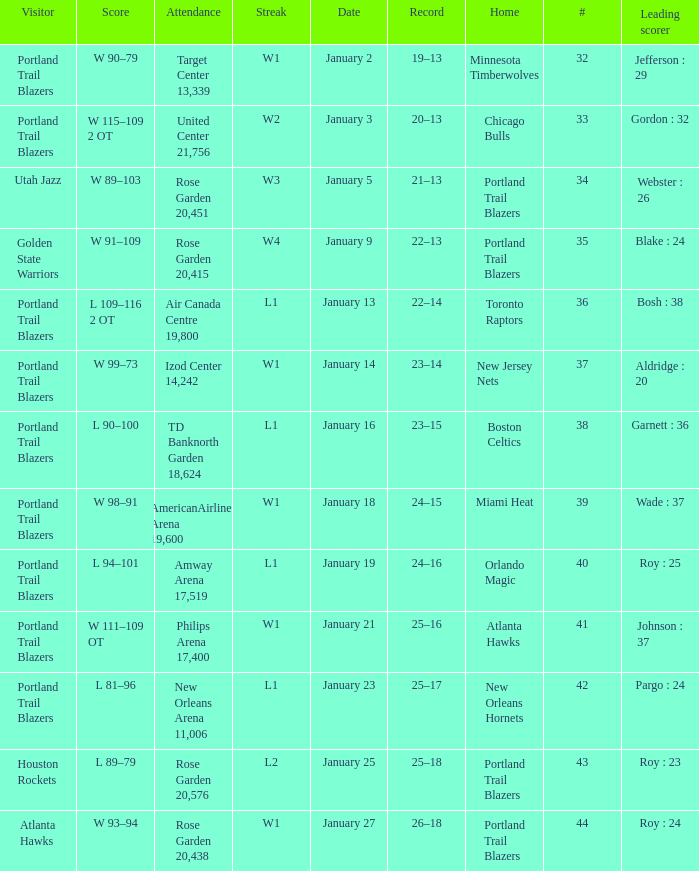Which visitors have a leading scorer of roy : 25 Portland Trail Blazers. 